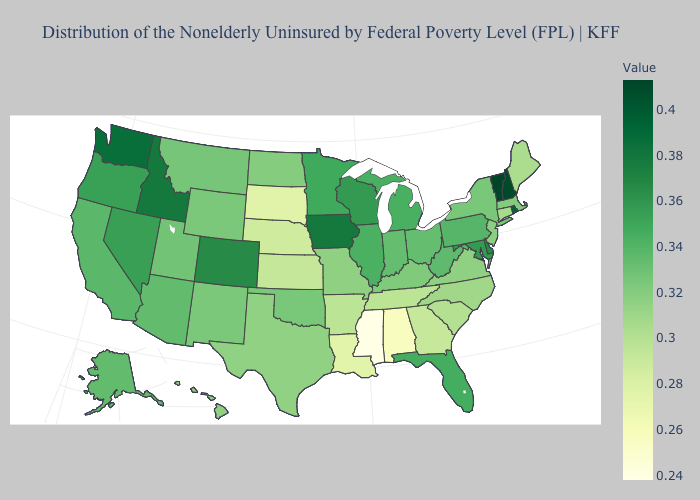Which states have the lowest value in the USA?
Concise answer only. Mississippi. Among the states that border Pennsylvania , does New York have the highest value?
Quick response, please. No. Which states have the lowest value in the MidWest?
Concise answer only. South Dakota. Does South Dakota have a higher value than South Carolina?
Short answer required. No. Which states have the lowest value in the USA?
Be succinct. Mississippi. Does Mississippi have the lowest value in the USA?
Concise answer only. Yes. Does the map have missing data?
Answer briefly. No. Among the states that border Florida , which have the highest value?
Answer briefly. Georgia. 